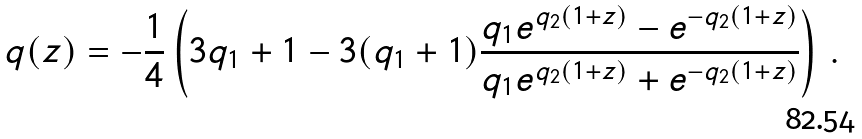Convert formula to latex. <formula><loc_0><loc_0><loc_500><loc_500>q ( z ) = - \frac { 1 } { 4 } \left ( 3 q _ { 1 } + 1 - 3 ( q _ { 1 } + 1 ) \frac { q _ { 1 } e ^ { q _ { 2 } ( 1 + z ) } - e ^ { - q _ { 2 } ( 1 + z ) } } { q _ { 1 } e ^ { q _ { 2 } ( 1 + z ) } + e ^ { - q _ { 2 } ( 1 + z ) } } \right ) \, .</formula> 